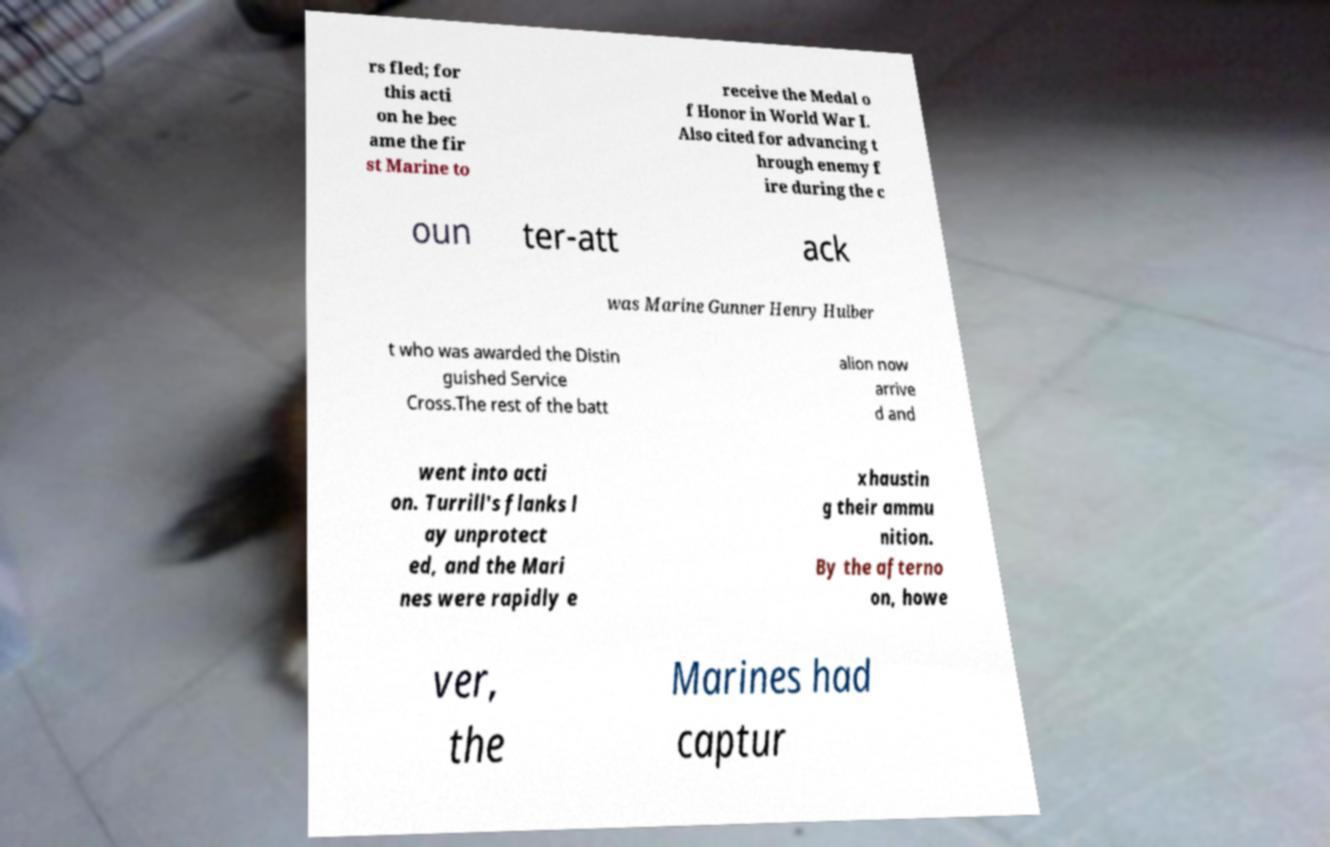Please identify and transcribe the text found in this image. rs fled; for this acti on he bec ame the fir st Marine to receive the Medal o f Honor in World War I. Also cited for advancing t hrough enemy f ire during the c oun ter-att ack was Marine Gunner Henry Hulber t who was awarded the Distin guished Service Cross.The rest of the batt alion now arrive d and went into acti on. Turrill's flanks l ay unprotect ed, and the Mari nes were rapidly e xhaustin g their ammu nition. By the afterno on, howe ver, the Marines had captur 